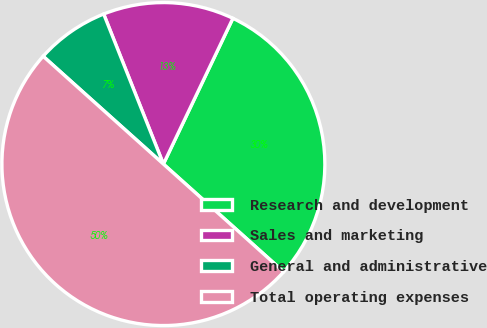<chart> <loc_0><loc_0><loc_500><loc_500><pie_chart><fcel>Research and development<fcel>Sales and marketing<fcel>General and administrative<fcel>Total operating expenses<nl><fcel>29.55%<fcel>13.11%<fcel>7.34%<fcel>50.0%<nl></chart> 